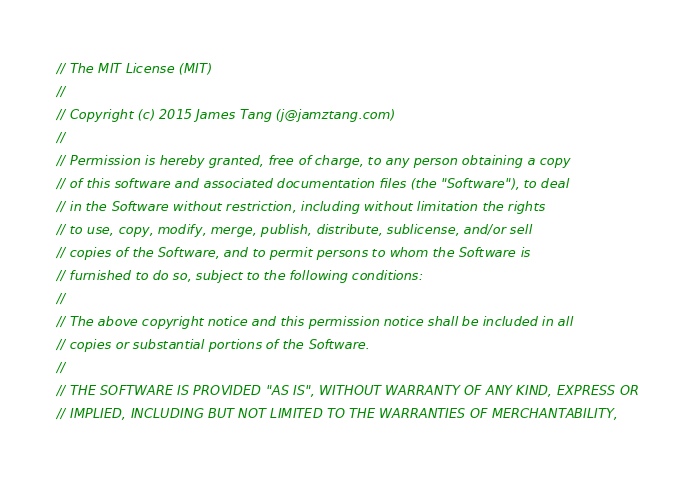<code> <loc_0><loc_0><loc_500><loc_500><_Swift_>// The MIT License (MIT)
//
// Copyright (c) 2015 James Tang (j@jamztang.com)
//
// Permission is hereby granted, free of charge, to any person obtaining a copy
// of this software and associated documentation files (the "Software"), to deal
// in the Software without restriction, including without limitation the rights
// to use, copy, modify, merge, publish, distribute, sublicense, and/or sell
// copies of the Software, and to permit persons to whom the Software is
// furnished to do so, subject to the following conditions:
//
// The above copyright notice and this permission notice shall be included in all
// copies or substantial portions of the Software.
//
// THE SOFTWARE IS PROVIDED "AS IS", WITHOUT WARRANTY OF ANY KIND, EXPRESS OR
// IMPLIED, INCLUDING BUT NOT LIMITED TO THE WARRANTIES OF MERCHANTABILITY,</code> 